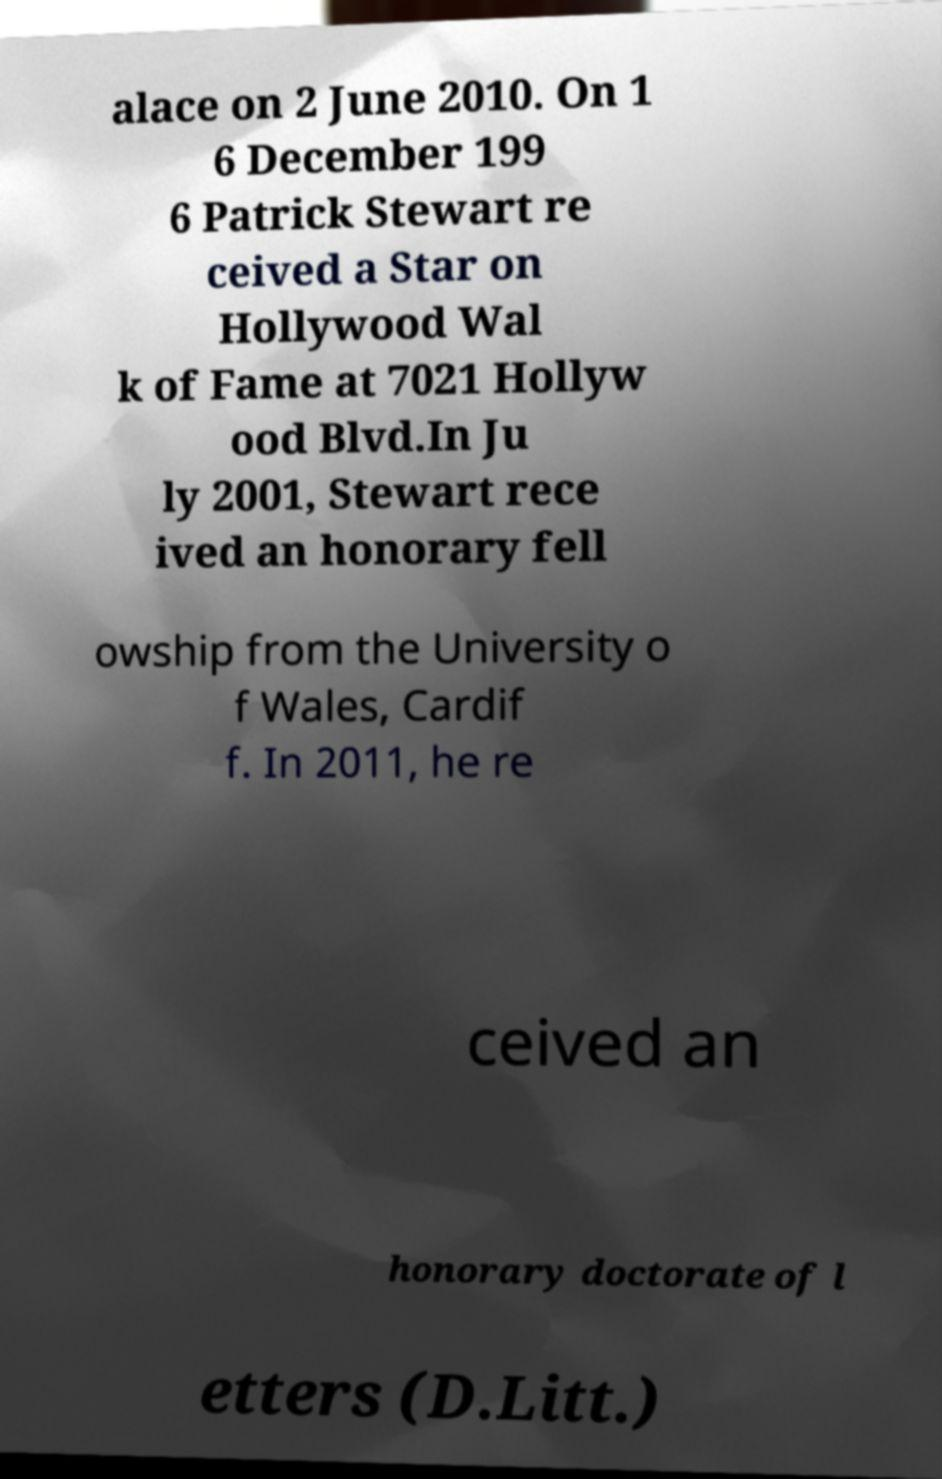There's text embedded in this image that I need extracted. Can you transcribe it verbatim? alace on 2 June 2010. On 1 6 December 199 6 Patrick Stewart re ceived a Star on Hollywood Wal k of Fame at 7021 Hollyw ood Blvd.In Ju ly 2001, Stewart rece ived an honorary fell owship from the University o f Wales, Cardif f. In 2011, he re ceived an honorary doctorate of l etters (D.Litt.) 